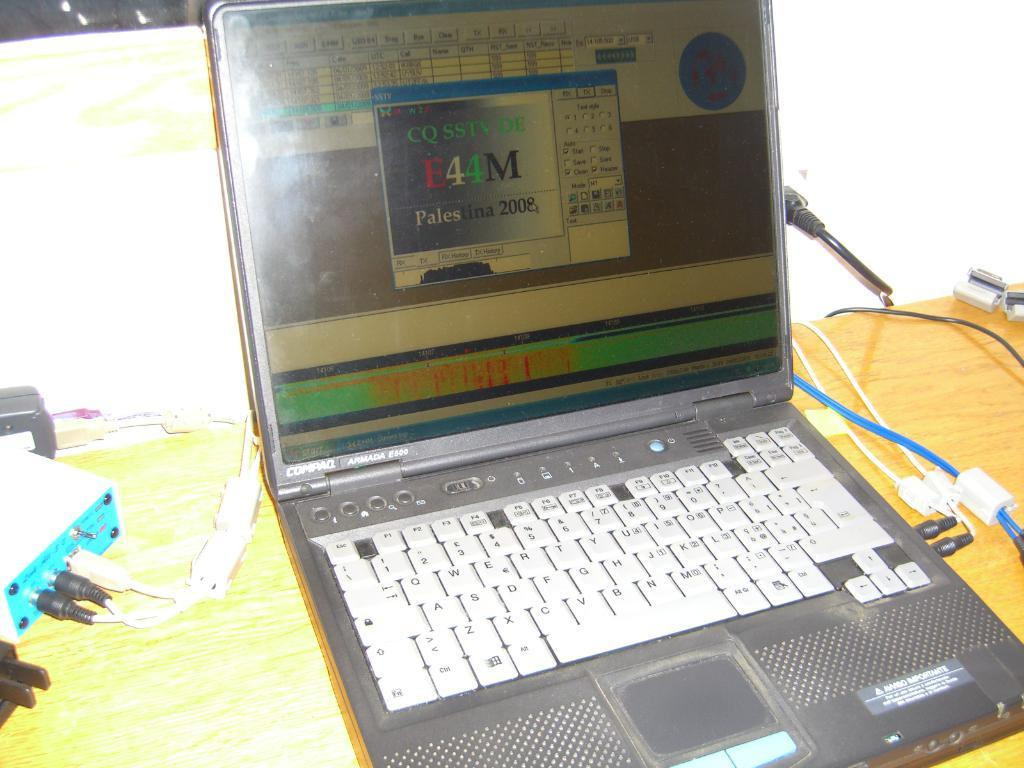<image>
Summarize the visual content of the image. Black laptop with white keys and a message saying "E44M" on the monitor. 